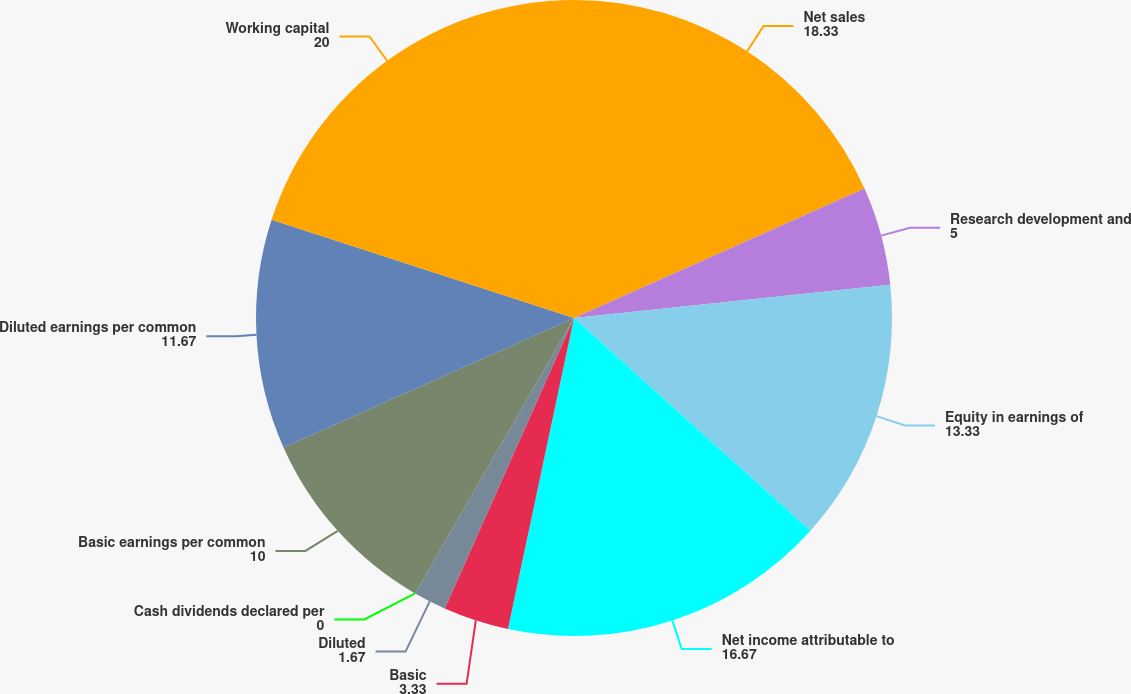<chart> <loc_0><loc_0><loc_500><loc_500><pie_chart><fcel>Net sales<fcel>Research development and<fcel>Equity in earnings of<fcel>Net income attributable to<fcel>Basic<fcel>Diluted<fcel>Cash dividends declared per<fcel>Basic earnings per common<fcel>Diluted earnings per common<fcel>Working capital<nl><fcel>18.33%<fcel>5.0%<fcel>13.33%<fcel>16.67%<fcel>3.33%<fcel>1.67%<fcel>0.0%<fcel>10.0%<fcel>11.67%<fcel>20.0%<nl></chart> 